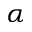<formula> <loc_0><loc_0><loc_500><loc_500>\alpha</formula> 